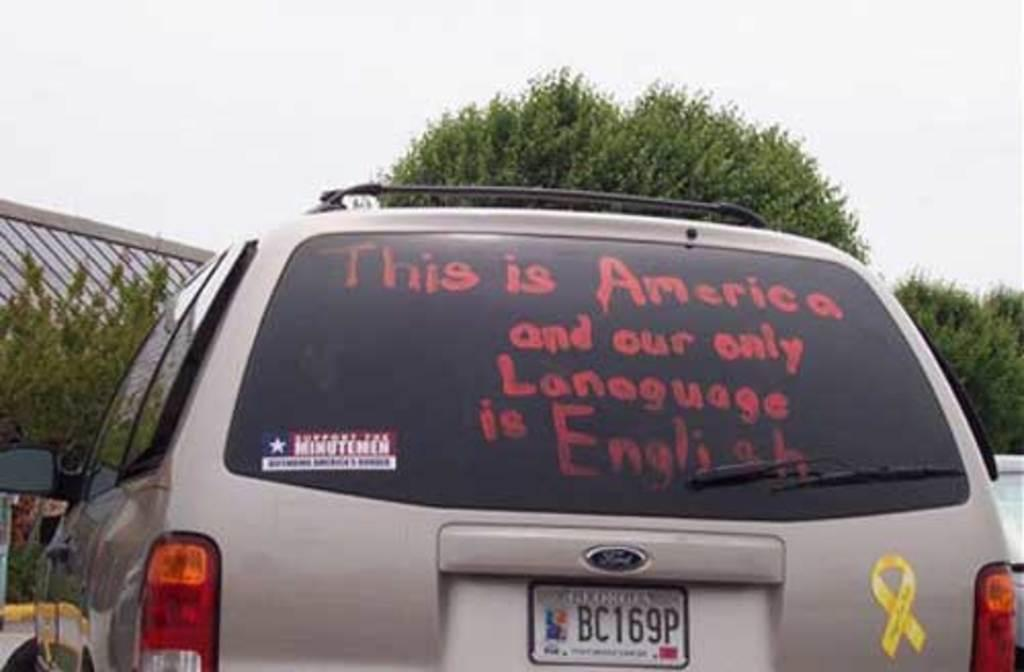<image>
Present a compact description of the photo's key features. Car with some writing on the back which says 'This is America". 